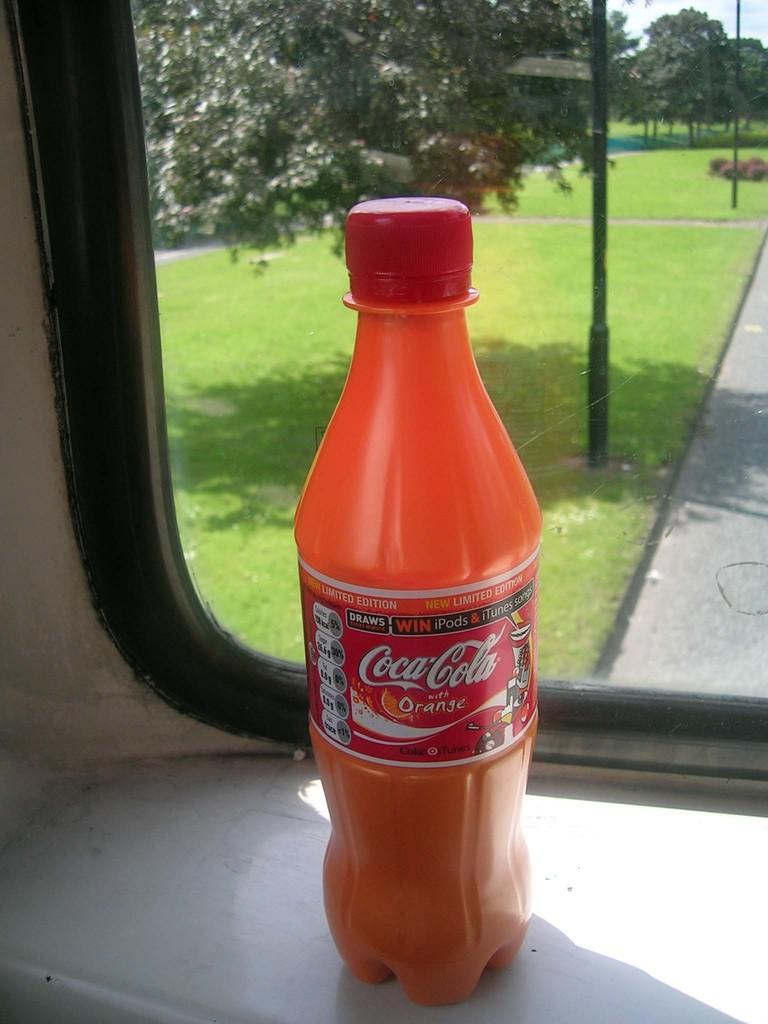<image>
Offer a succinct explanation of the picture presented. A bottle of Coca-Cola with Orange is in the window of a camper. 